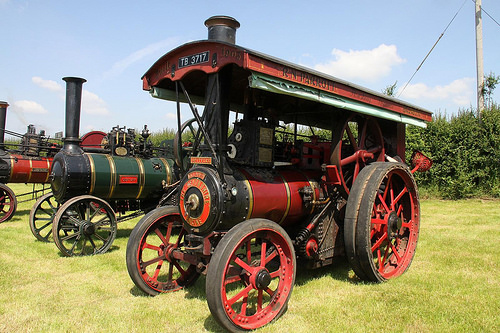<image>
Is there a wheel to the left of the wheel? Yes. From this viewpoint, the wheel is positioned to the left side relative to the wheel. 